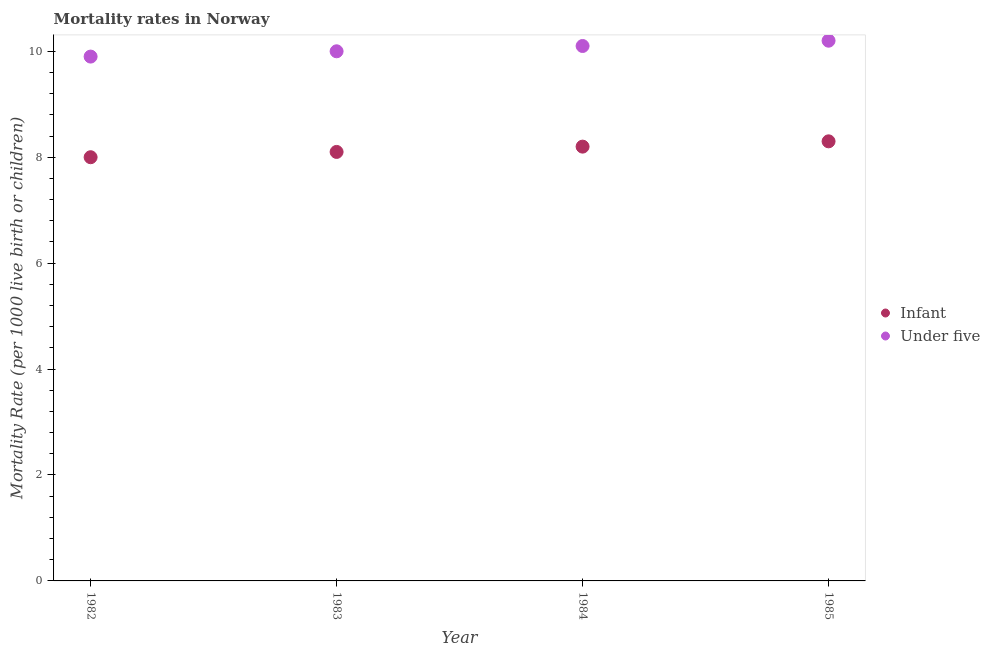How many different coloured dotlines are there?
Provide a short and direct response. 2. What is the infant mortality rate in 1985?
Your answer should be very brief. 8.3. Across all years, what is the minimum infant mortality rate?
Your answer should be very brief. 8. In which year was the infant mortality rate maximum?
Offer a terse response. 1985. In which year was the infant mortality rate minimum?
Provide a short and direct response. 1982. What is the total under-5 mortality rate in the graph?
Ensure brevity in your answer.  40.2. What is the difference between the infant mortality rate in 1983 and that in 1985?
Offer a very short reply. -0.2. What is the difference between the under-5 mortality rate in 1985 and the infant mortality rate in 1982?
Your answer should be very brief. 2.2. What is the average infant mortality rate per year?
Offer a terse response. 8.15. In the year 1984, what is the difference between the infant mortality rate and under-5 mortality rate?
Make the answer very short. -1.9. What is the ratio of the infant mortality rate in 1982 to that in 1985?
Provide a short and direct response. 0.96. Is the difference between the under-5 mortality rate in 1982 and 1985 greater than the difference between the infant mortality rate in 1982 and 1985?
Give a very brief answer. Yes. What is the difference between the highest and the second highest infant mortality rate?
Offer a very short reply. 0.1. What is the difference between the highest and the lowest under-5 mortality rate?
Your answer should be compact. 0.3. Is the infant mortality rate strictly greater than the under-5 mortality rate over the years?
Make the answer very short. No. How many years are there in the graph?
Your answer should be compact. 4. Are the values on the major ticks of Y-axis written in scientific E-notation?
Your answer should be very brief. No. Does the graph contain any zero values?
Provide a succinct answer. No. Does the graph contain grids?
Your answer should be very brief. No. What is the title of the graph?
Your answer should be very brief. Mortality rates in Norway. What is the label or title of the Y-axis?
Keep it short and to the point. Mortality Rate (per 1000 live birth or children). What is the Mortality Rate (per 1000 live birth or children) in Infant in 1982?
Ensure brevity in your answer.  8. What is the Mortality Rate (per 1000 live birth or children) in Infant in 1983?
Your response must be concise. 8.1. What is the Mortality Rate (per 1000 live birth or children) in Under five in 1985?
Provide a succinct answer. 10.2. What is the total Mortality Rate (per 1000 live birth or children) in Infant in the graph?
Make the answer very short. 32.6. What is the total Mortality Rate (per 1000 live birth or children) in Under five in the graph?
Your answer should be compact. 40.2. What is the difference between the Mortality Rate (per 1000 live birth or children) in Under five in 1982 and that in 1983?
Your answer should be very brief. -0.1. What is the difference between the Mortality Rate (per 1000 live birth or children) of Infant in 1983 and that in 1984?
Make the answer very short. -0.1. What is the difference between the Mortality Rate (per 1000 live birth or children) in Infant in 1982 and the Mortality Rate (per 1000 live birth or children) in Under five in 1984?
Keep it short and to the point. -2.1. What is the difference between the Mortality Rate (per 1000 live birth or children) in Infant in 1984 and the Mortality Rate (per 1000 live birth or children) in Under five in 1985?
Ensure brevity in your answer.  -2. What is the average Mortality Rate (per 1000 live birth or children) of Infant per year?
Offer a very short reply. 8.15. What is the average Mortality Rate (per 1000 live birth or children) of Under five per year?
Your answer should be very brief. 10.05. In the year 1983, what is the difference between the Mortality Rate (per 1000 live birth or children) in Infant and Mortality Rate (per 1000 live birth or children) in Under five?
Ensure brevity in your answer.  -1.9. In the year 1984, what is the difference between the Mortality Rate (per 1000 live birth or children) in Infant and Mortality Rate (per 1000 live birth or children) in Under five?
Keep it short and to the point. -1.9. What is the ratio of the Mortality Rate (per 1000 live birth or children) of Under five in 1982 to that in 1983?
Your answer should be compact. 0.99. What is the ratio of the Mortality Rate (per 1000 live birth or children) of Infant in 1982 to that in 1984?
Your response must be concise. 0.98. What is the ratio of the Mortality Rate (per 1000 live birth or children) in Under five in 1982 to that in 1984?
Provide a succinct answer. 0.98. What is the ratio of the Mortality Rate (per 1000 live birth or children) in Infant in 1982 to that in 1985?
Offer a very short reply. 0.96. What is the ratio of the Mortality Rate (per 1000 live birth or children) in Under five in 1982 to that in 1985?
Keep it short and to the point. 0.97. What is the ratio of the Mortality Rate (per 1000 live birth or children) of Under five in 1983 to that in 1984?
Your answer should be compact. 0.99. What is the ratio of the Mortality Rate (per 1000 live birth or children) in Infant in 1983 to that in 1985?
Offer a very short reply. 0.98. What is the ratio of the Mortality Rate (per 1000 live birth or children) of Under five in 1983 to that in 1985?
Your answer should be very brief. 0.98. What is the ratio of the Mortality Rate (per 1000 live birth or children) of Under five in 1984 to that in 1985?
Make the answer very short. 0.99. What is the difference between the highest and the second highest Mortality Rate (per 1000 live birth or children) in Under five?
Keep it short and to the point. 0.1. 